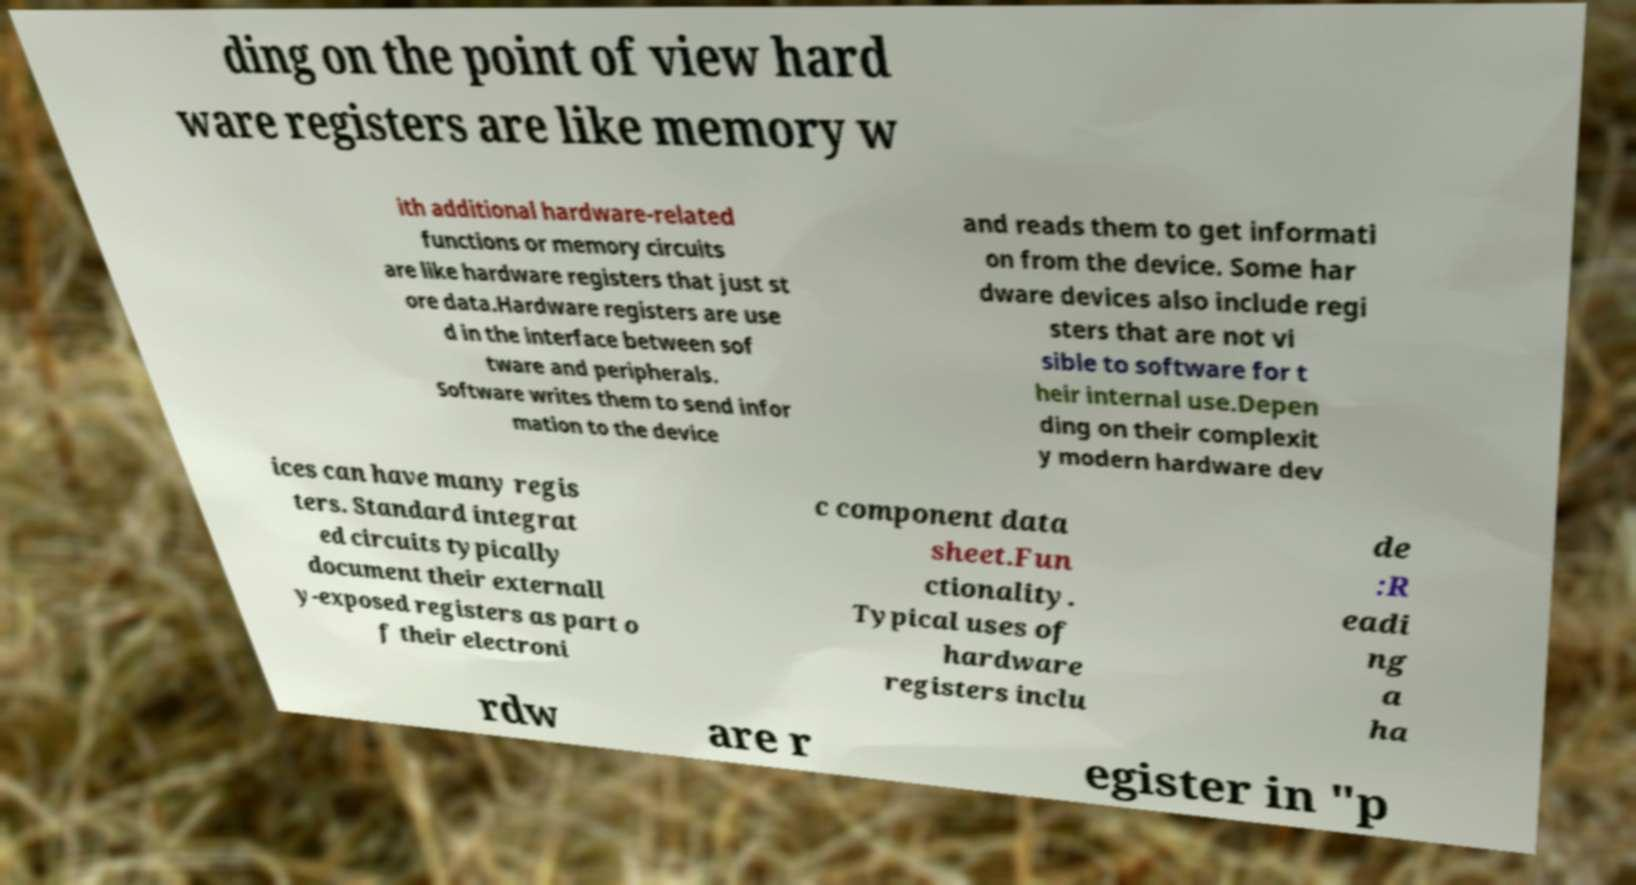I need the written content from this picture converted into text. Can you do that? ding on the point of view hard ware registers are like memory w ith additional hardware-related functions or memory circuits are like hardware registers that just st ore data.Hardware registers are use d in the interface between sof tware and peripherals. Software writes them to send infor mation to the device and reads them to get informati on from the device. Some har dware devices also include regi sters that are not vi sible to software for t heir internal use.Depen ding on their complexit y modern hardware dev ices can have many regis ters. Standard integrat ed circuits typically document their externall y-exposed registers as part o f their electroni c component data sheet.Fun ctionality. Typical uses of hardware registers inclu de :R eadi ng a ha rdw are r egister in "p 